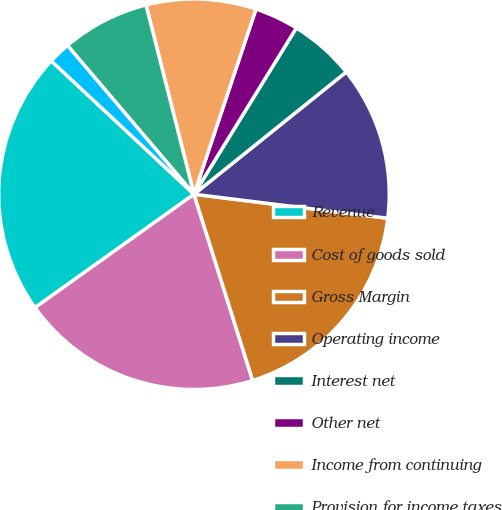Convert chart to OTSL. <chart><loc_0><loc_0><loc_500><loc_500><pie_chart><fcel>Revenue<fcel>Cost of goods sold<fcel>Gross Margin<fcel>Operating income<fcel>Interest net<fcel>Other net<fcel>Income from continuing<fcel>Provision for income taxes<fcel>Basic earnings per share from<nl><fcel>21.82%<fcel>20.0%<fcel>18.18%<fcel>12.73%<fcel>5.45%<fcel>3.64%<fcel>9.09%<fcel>7.27%<fcel>1.82%<nl></chart> 